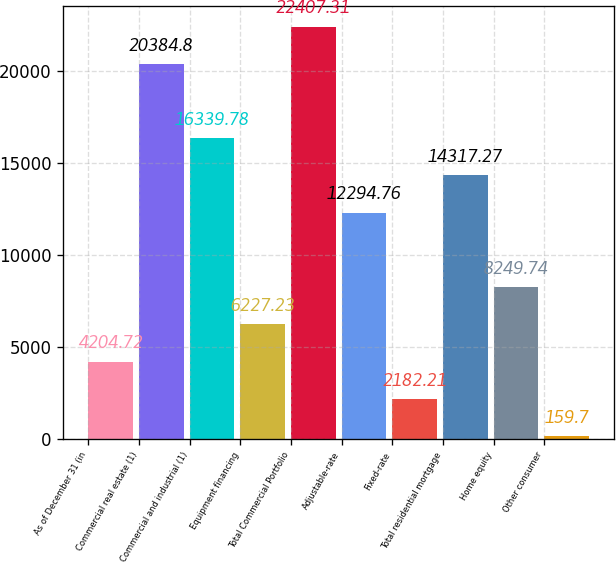Convert chart to OTSL. <chart><loc_0><loc_0><loc_500><loc_500><bar_chart><fcel>As of December 31 (in<fcel>Commercial real estate (1)<fcel>Commercial and industrial (1)<fcel>Equipment financing<fcel>Total Commercial Portfolio<fcel>Adjustable-rate<fcel>Fixed-rate<fcel>Total residential mortgage<fcel>Home equity<fcel>Other consumer<nl><fcel>4204.72<fcel>20384.8<fcel>16339.8<fcel>6227.23<fcel>22407.3<fcel>12294.8<fcel>2182.21<fcel>14317.3<fcel>8249.74<fcel>159.7<nl></chart> 